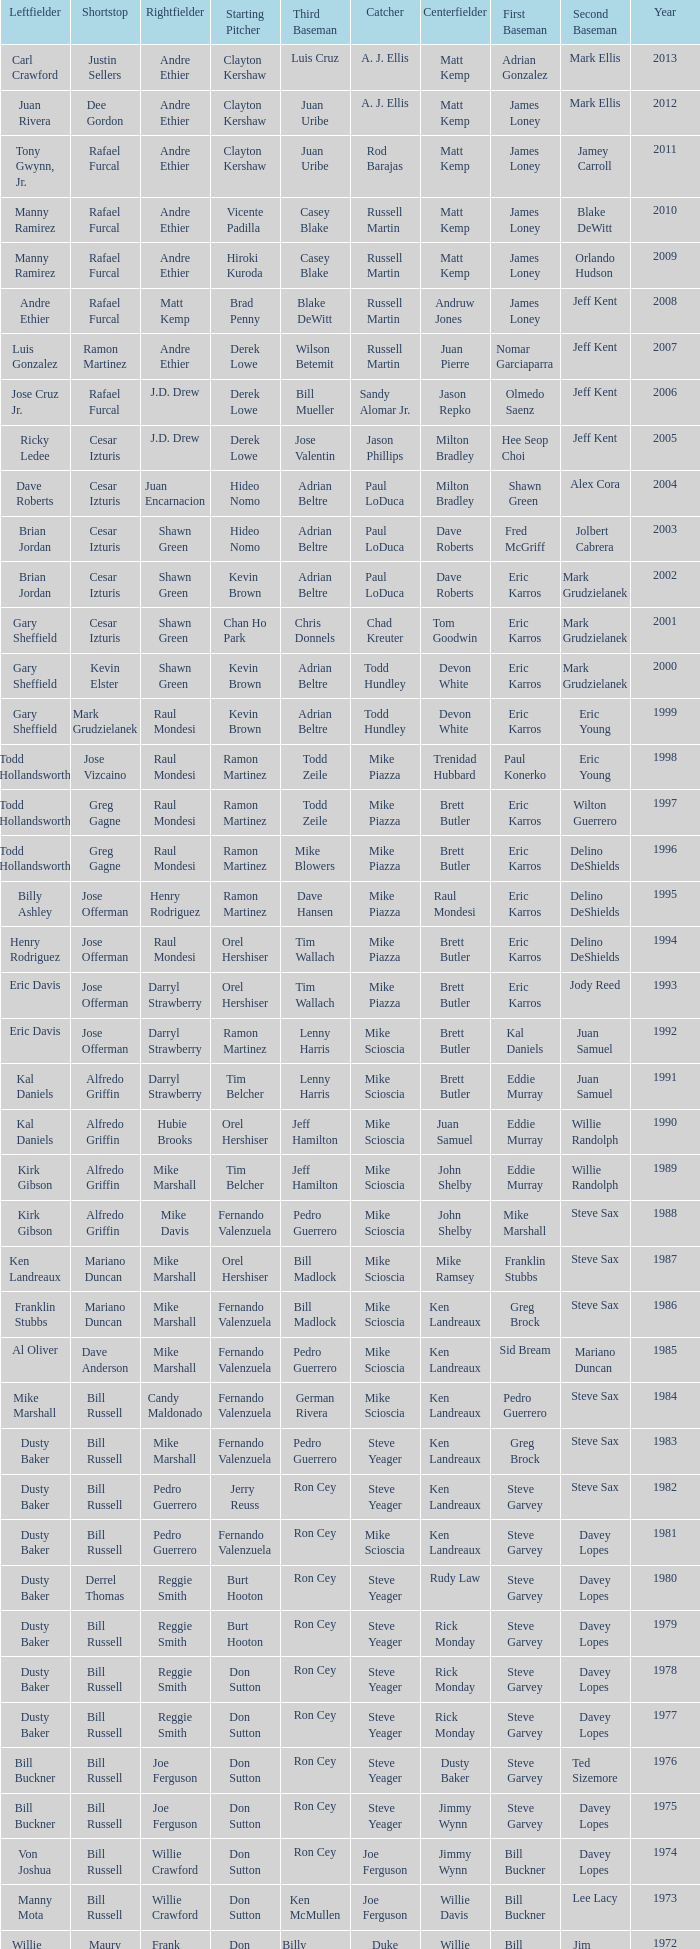Who was the RF when the SP was vicente padilla? Andre Ethier. 